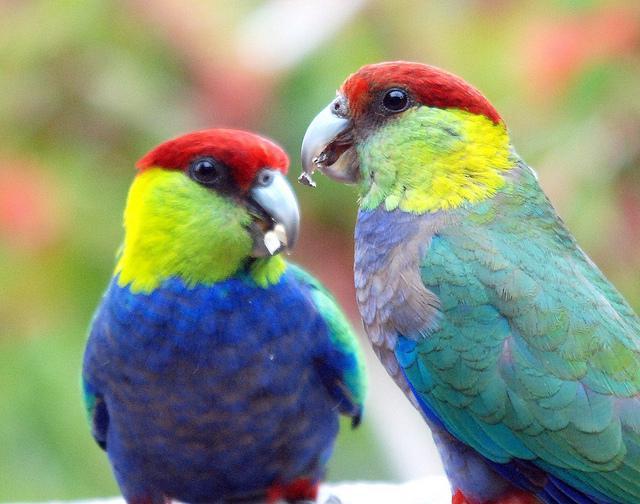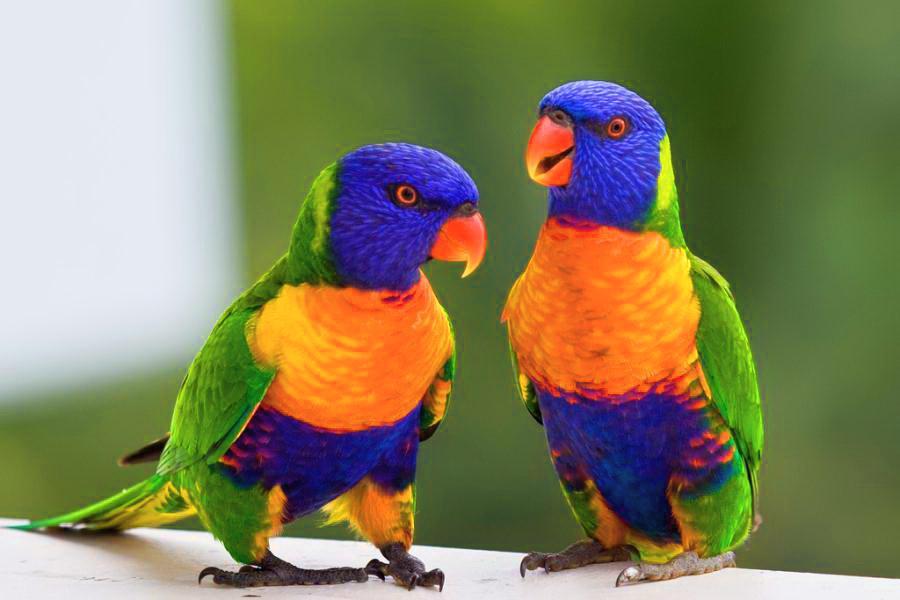The first image is the image on the left, the second image is the image on the right. Assess this claim about the two images: "There are a total of three birds". Correct or not? Answer yes or no. No. 